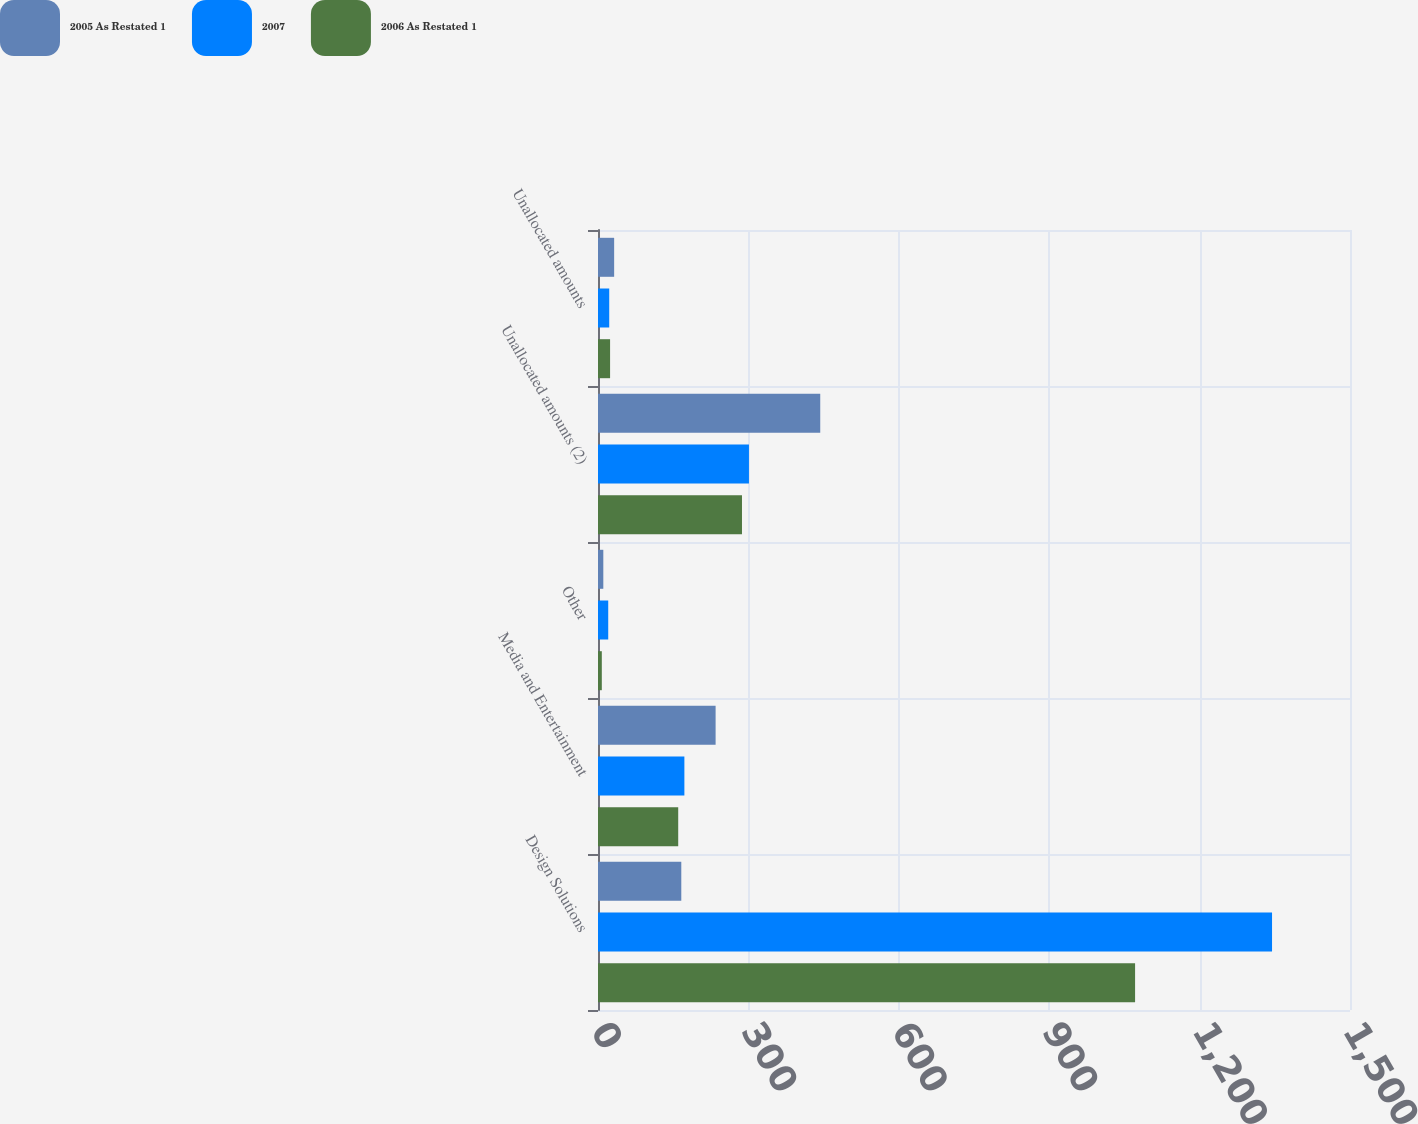Convert chart. <chart><loc_0><loc_0><loc_500><loc_500><stacked_bar_chart><ecel><fcel>Design Solutions<fcel>Media and Entertainment<fcel>Other<fcel>Unallocated amounts (2)<fcel>Unallocated amounts<nl><fcel>2005 As Restated 1<fcel>166.15<fcel>234.6<fcel>10.6<fcel>443.3<fcel>32.2<nl><fcel>2007<fcel>1344.5<fcel>172.3<fcel>20.4<fcel>301.1<fcel>22.4<nl><fcel>2006 As Restated 1<fcel>1071.3<fcel>160<fcel>7.6<fcel>287.2<fcel>24.1<nl></chart> 